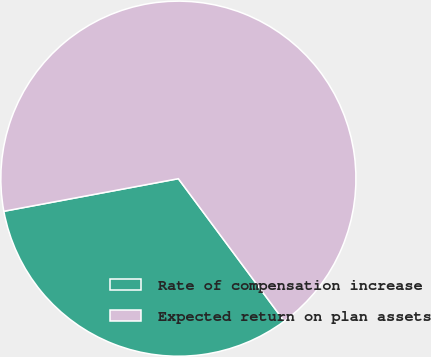<chart> <loc_0><loc_0><loc_500><loc_500><pie_chart><fcel>Rate of compensation increase<fcel>Expected return on plan assets<nl><fcel>32.23%<fcel>67.77%<nl></chart> 